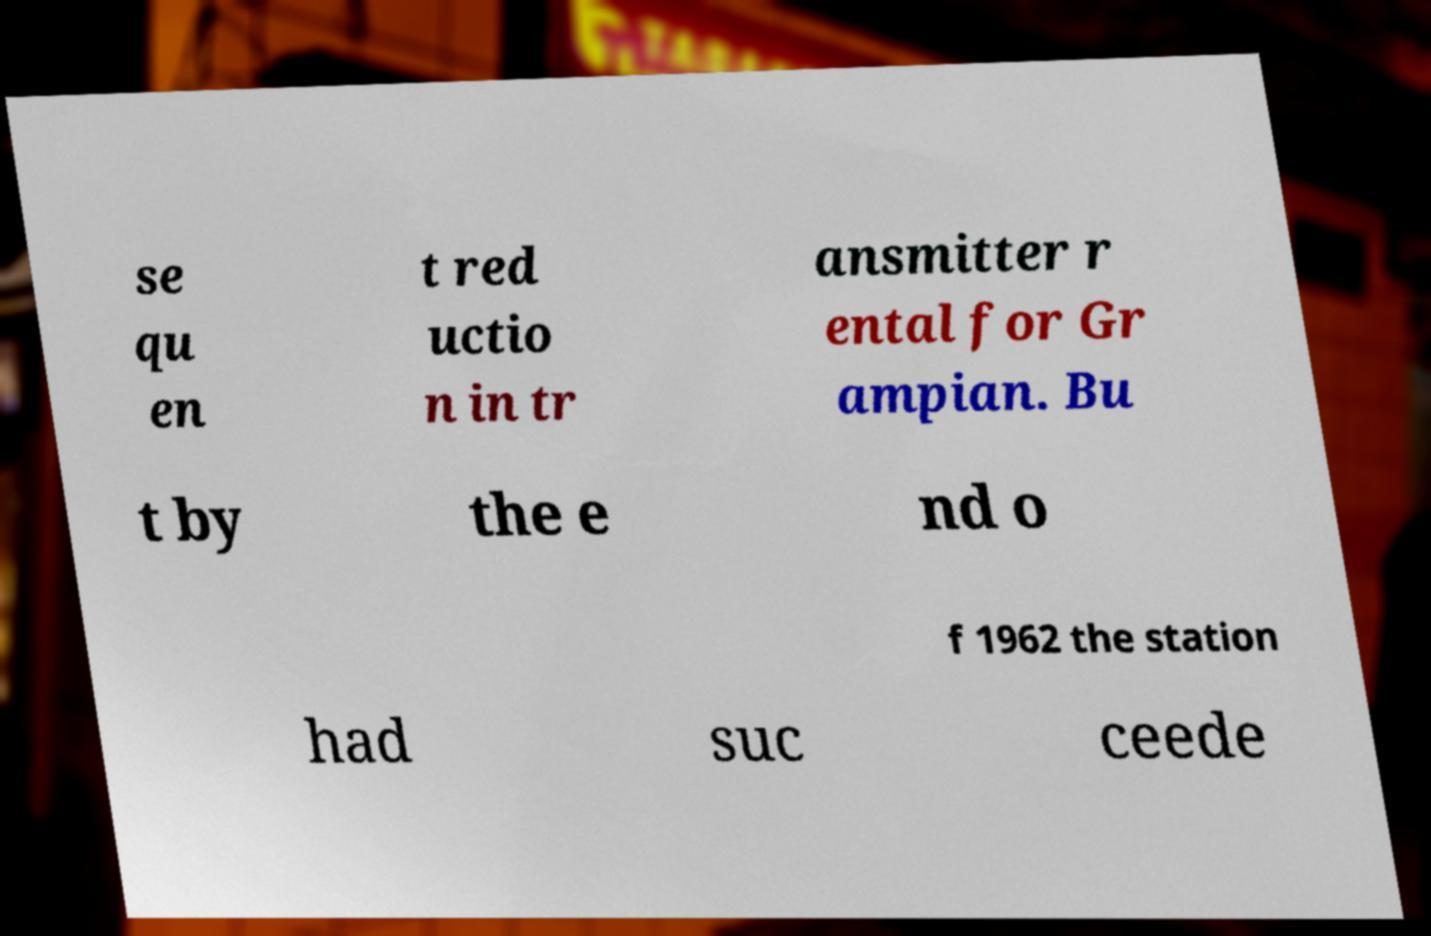Can you accurately transcribe the text from the provided image for me? se qu en t red uctio n in tr ansmitter r ental for Gr ampian. Bu t by the e nd o f 1962 the station had suc ceede 